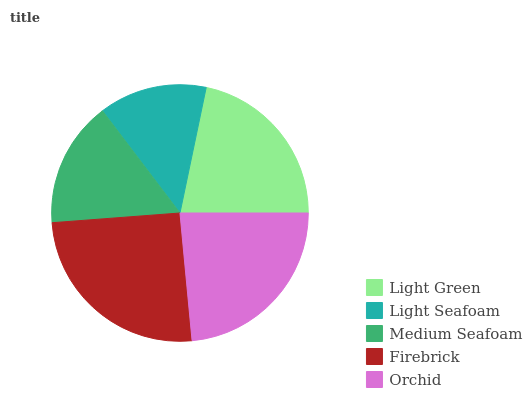Is Light Seafoam the minimum?
Answer yes or no. Yes. Is Firebrick the maximum?
Answer yes or no. Yes. Is Medium Seafoam the minimum?
Answer yes or no. No. Is Medium Seafoam the maximum?
Answer yes or no. No. Is Medium Seafoam greater than Light Seafoam?
Answer yes or no. Yes. Is Light Seafoam less than Medium Seafoam?
Answer yes or no. Yes. Is Light Seafoam greater than Medium Seafoam?
Answer yes or no. No. Is Medium Seafoam less than Light Seafoam?
Answer yes or no. No. Is Light Green the high median?
Answer yes or no. Yes. Is Light Green the low median?
Answer yes or no. Yes. Is Orchid the high median?
Answer yes or no. No. Is Orchid the low median?
Answer yes or no. No. 